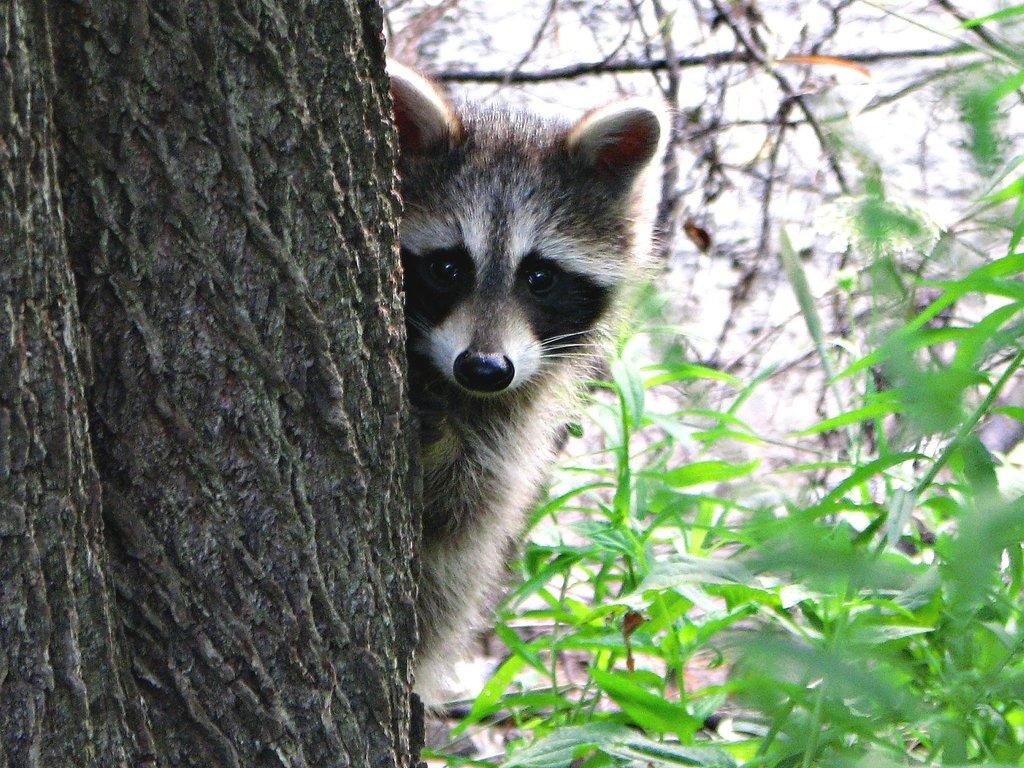What type of animal is beside the trunk in the image? The specific type of animal cannot be determined from the provided facts. What else can be seen in the image besides the animal and trunk? There are plants in the image. How would you describe the background of the image? The background of the image is blurred. What type of clover is growing near the animal's mouth in the image? There is no clover or mention of a mouth in the image. 